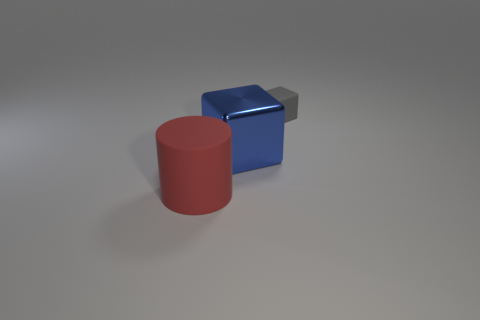Is the number of red objects that are right of the red thing the same as the number of blue shiny balls?
Make the answer very short. Yes. What number of brown spheres are there?
Provide a succinct answer. 0. There is a object that is behind the big red object and in front of the small matte object; what is its shape?
Provide a succinct answer. Cube. Are there any small objects made of the same material as the tiny gray block?
Keep it short and to the point. No. Is the number of blue cubes behind the gray thing the same as the number of tiny gray rubber blocks that are behind the big metal cube?
Offer a very short reply. No. There is a cube that is on the left side of the gray cube; how big is it?
Your answer should be very brief. Large. The object in front of the large thing behind the large red rubber cylinder is made of what material?
Offer a very short reply. Rubber. How many tiny matte objects are behind the cube that is left of the thing that is right of the big metal block?
Provide a short and direct response. 1. Is the material of the object right of the metal thing the same as the large red cylinder in front of the large metal cube?
Your answer should be very brief. Yes. How many gray rubber things have the same shape as the large blue object?
Your answer should be very brief. 1. 